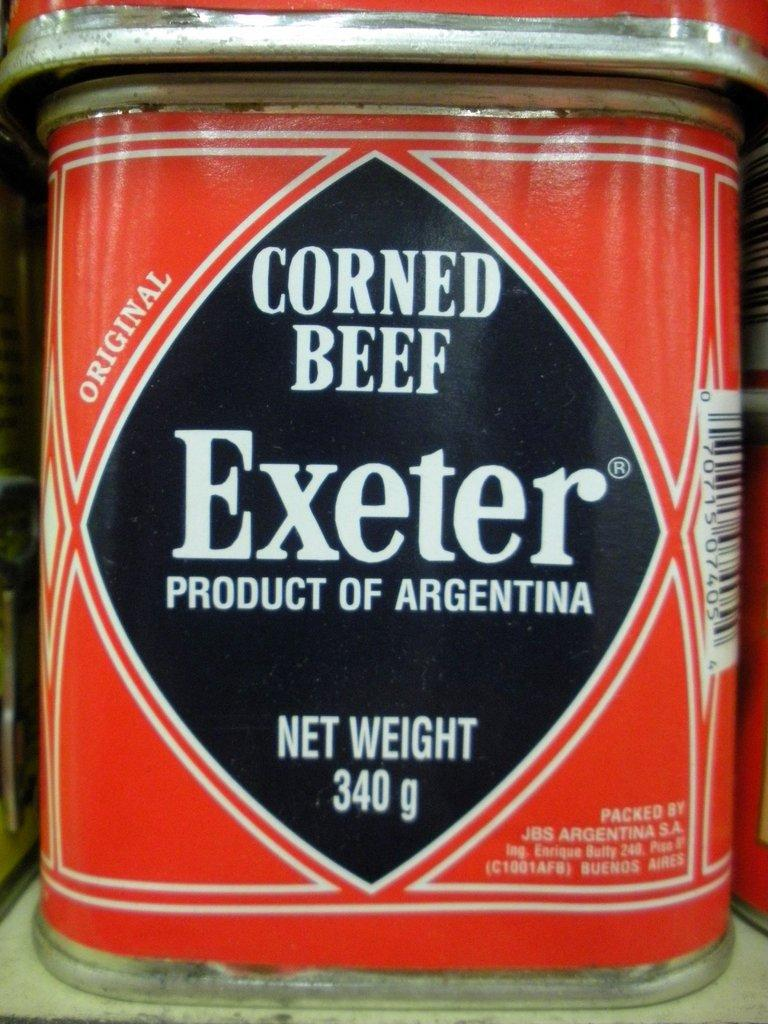<image>
Describe the image concisely. A can of corned beef exeter with a net weight of 340g. 